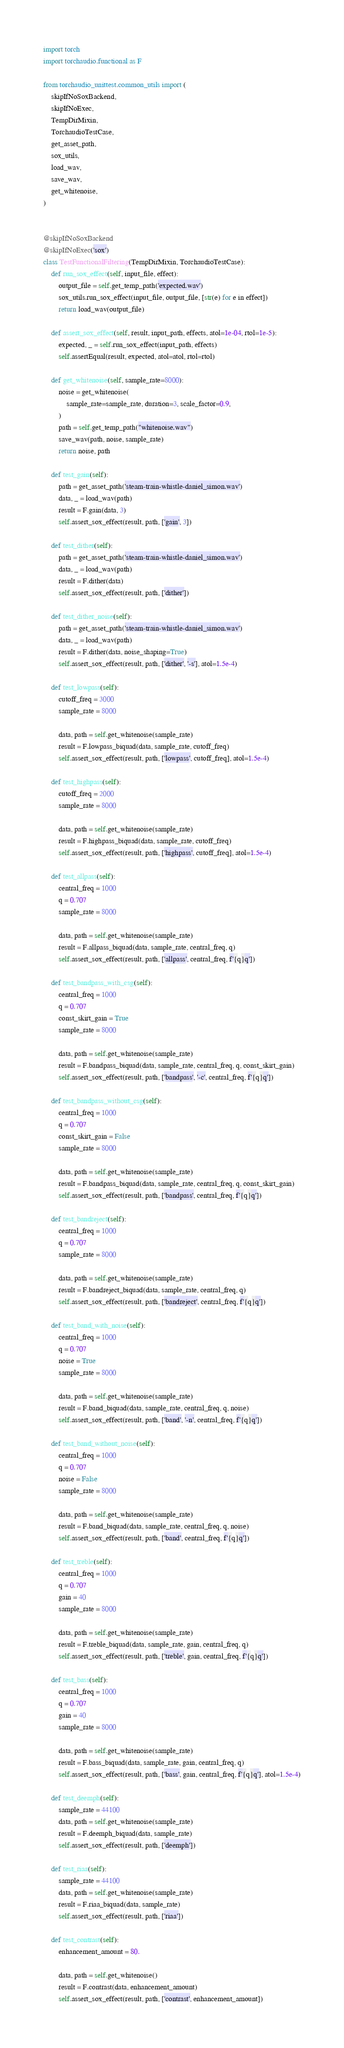Convert code to text. <code><loc_0><loc_0><loc_500><loc_500><_Python_>import torch
import torchaudio.functional as F

from torchaudio_unittest.common_utils import (
    skipIfNoSoxBackend,
    skipIfNoExec,
    TempDirMixin,
    TorchaudioTestCase,
    get_asset_path,
    sox_utils,
    load_wav,
    save_wav,
    get_whitenoise,
)


@skipIfNoSoxBackend
@skipIfNoExec('sox')
class TestFunctionalFiltering(TempDirMixin, TorchaudioTestCase):
    def run_sox_effect(self, input_file, effect):
        output_file = self.get_temp_path('expected.wav')
        sox_utils.run_sox_effect(input_file, output_file, [str(e) for e in effect])
        return load_wav(output_file)

    def assert_sox_effect(self, result, input_path, effects, atol=1e-04, rtol=1e-5):
        expected, _ = self.run_sox_effect(input_path, effects)
        self.assertEqual(result, expected, atol=atol, rtol=rtol)

    def get_whitenoise(self, sample_rate=8000):
        noise = get_whitenoise(
            sample_rate=sample_rate, duration=3, scale_factor=0.9,
        )
        path = self.get_temp_path("whitenoise.wav")
        save_wav(path, noise, sample_rate)
        return noise, path

    def test_gain(self):
        path = get_asset_path('steam-train-whistle-daniel_simon.wav')
        data, _ = load_wav(path)
        result = F.gain(data, 3)
        self.assert_sox_effect(result, path, ['gain', 3])

    def test_dither(self):
        path = get_asset_path('steam-train-whistle-daniel_simon.wav')
        data, _ = load_wav(path)
        result = F.dither(data)
        self.assert_sox_effect(result, path, ['dither'])

    def test_dither_noise(self):
        path = get_asset_path('steam-train-whistle-daniel_simon.wav')
        data, _ = load_wav(path)
        result = F.dither(data, noise_shaping=True)
        self.assert_sox_effect(result, path, ['dither', '-s'], atol=1.5e-4)

    def test_lowpass(self):
        cutoff_freq = 3000
        sample_rate = 8000

        data, path = self.get_whitenoise(sample_rate)
        result = F.lowpass_biquad(data, sample_rate, cutoff_freq)
        self.assert_sox_effect(result, path, ['lowpass', cutoff_freq], atol=1.5e-4)

    def test_highpass(self):
        cutoff_freq = 2000
        sample_rate = 8000

        data, path = self.get_whitenoise(sample_rate)
        result = F.highpass_biquad(data, sample_rate, cutoff_freq)
        self.assert_sox_effect(result, path, ['highpass', cutoff_freq], atol=1.5e-4)

    def test_allpass(self):
        central_freq = 1000
        q = 0.707
        sample_rate = 8000

        data, path = self.get_whitenoise(sample_rate)
        result = F.allpass_biquad(data, sample_rate, central_freq, q)
        self.assert_sox_effect(result, path, ['allpass', central_freq, f'{q}q'])

    def test_bandpass_with_csg(self):
        central_freq = 1000
        q = 0.707
        const_skirt_gain = True
        sample_rate = 8000

        data, path = self.get_whitenoise(sample_rate)
        result = F.bandpass_biquad(data, sample_rate, central_freq, q, const_skirt_gain)
        self.assert_sox_effect(result, path, ['bandpass', '-c', central_freq, f'{q}q'])

    def test_bandpass_without_csg(self):
        central_freq = 1000
        q = 0.707
        const_skirt_gain = False
        sample_rate = 8000

        data, path = self.get_whitenoise(sample_rate)
        result = F.bandpass_biquad(data, sample_rate, central_freq, q, const_skirt_gain)
        self.assert_sox_effect(result, path, ['bandpass', central_freq, f'{q}q'])

    def test_bandreject(self):
        central_freq = 1000
        q = 0.707
        sample_rate = 8000

        data, path = self.get_whitenoise(sample_rate)
        result = F.bandreject_biquad(data, sample_rate, central_freq, q)
        self.assert_sox_effect(result, path, ['bandreject', central_freq, f'{q}q'])

    def test_band_with_noise(self):
        central_freq = 1000
        q = 0.707
        noise = True
        sample_rate = 8000

        data, path = self.get_whitenoise(sample_rate)
        result = F.band_biquad(data, sample_rate, central_freq, q, noise)
        self.assert_sox_effect(result, path, ['band', '-n', central_freq, f'{q}q'])

    def test_band_without_noise(self):
        central_freq = 1000
        q = 0.707
        noise = False
        sample_rate = 8000

        data, path = self.get_whitenoise(sample_rate)
        result = F.band_biquad(data, sample_rate, central_freq, q, noise)
        self.assert_sox_effect(result, path, ['band', central_freq, f'{q}q'])

    def test_treble(self):
        central_freq = 1000
        q = 0.707
        gain = 40
        sample_rate = 8000

        data, path = self.get_whitenoise(sample_rate)
        result = F.treble_biquad(data, sample_rate, gain, central_freq, q)
        self.assert_sox_effect(result, path, ['treble', gain, central_freq, f'{q}q'])

    def test_bass(self):
        central_freq = 1000
        q = 0.707
        gain = 40
        sample_rate = 8000

        data, path = self.get_whitenoise(sample_rate)
        result = F.bass_biquad(data, sample_rate, gain, central_freq, q)
        self.assert_sox_effect(result, path, ['bass', gain, central_freq, f'{q}q'], atol=1.5e-4)

    def test_deemph(self):
        sample_rate = 44100
        data, path = self.get_whitenoise(sample_rate)
        result = F.deemph_biquad(data, sample_rate)
        self.assert_sox_effect(result, path, ['deemph'])

    def test_riaa(self):
        sample_rate = 44100
        data, path = self.get_whitenoise(sample_rate)
        result = F.riaa_biquad(data, sample_rate)
        self.assert_sox_effect(result, path, ['riaa'])

    def test_contrast(self):
        enhancement_amount = 80.

        data, path = self.get_whitenoise()
        result = F.contrast(data, enhancement_amount)
        self.assert_sox_effect(result, path, ['contrast', enhancement_amount])
</code> 